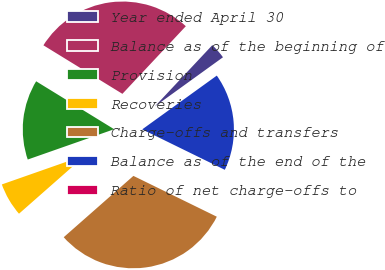Convert chart. <chart><loc_0><loc_0><loc_500><loc_500><pie_chart><fcel>Year ended April 30<fcel>Balance as of the beginning of<fcel>Provision<fcel>Recoveries<fcel>Charge-offs and transfers<fcel>Balance as of the end of the<fcel>Ratio of net charge-offs to<nl><fcel>3.06%<fcel>28.22%<fcel>14.14%<fcel>6.12%<fcel>31.27%<fcel>17.19%<fcel>0.01%<nl></chart> 